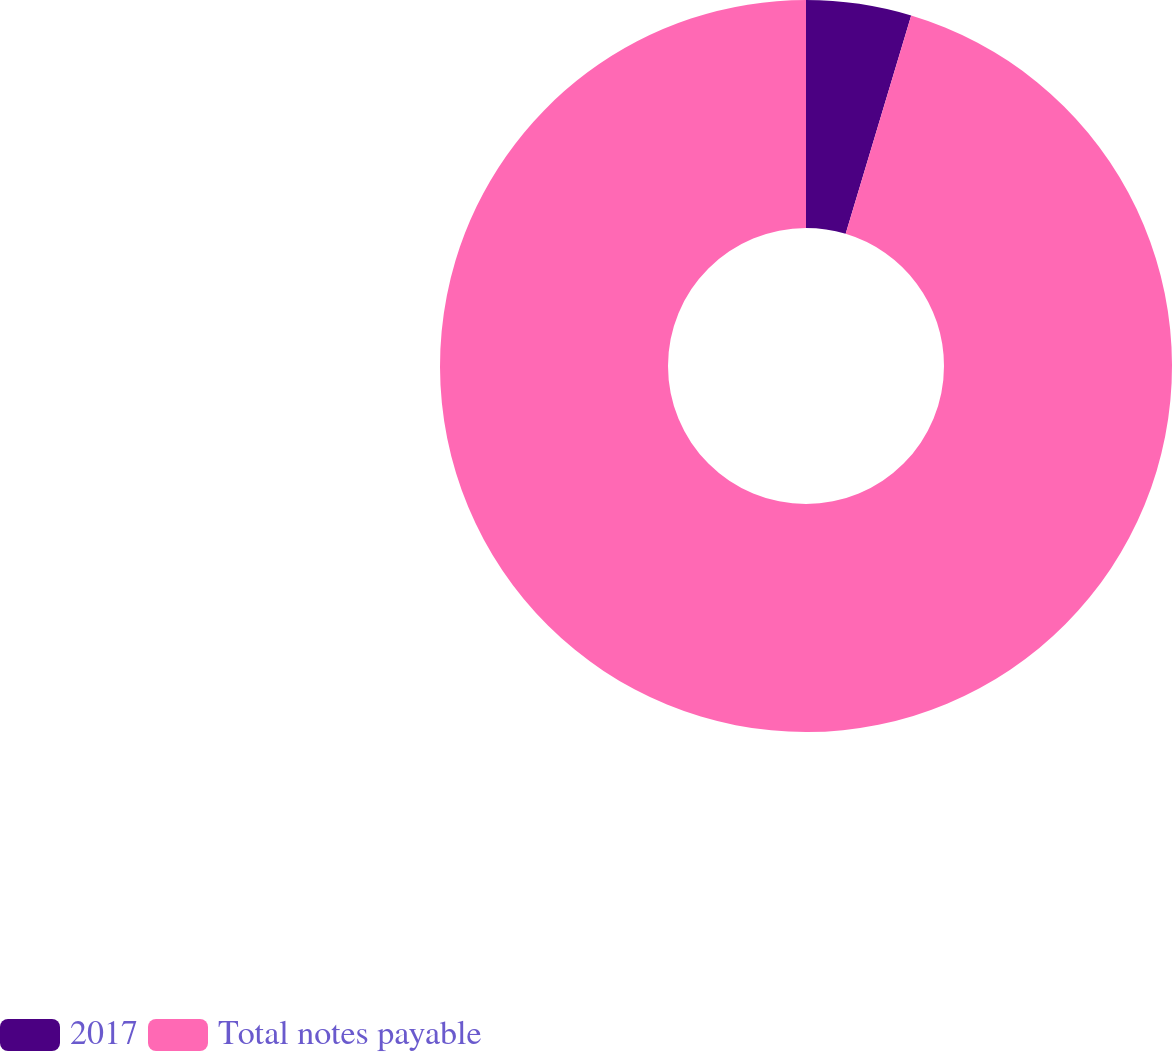<chart> <loc_0><loc_0><loc_500><loc_500><pie_chart><fcel>2017<fcel>Total notes payable<nl><fcel>4.64%<fcel>95.36%<nl></chart> 